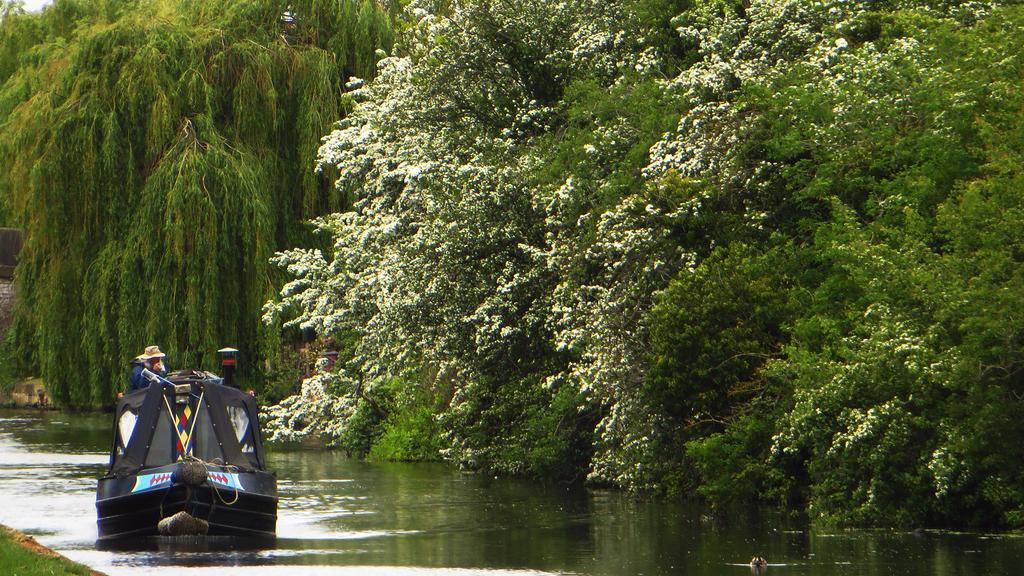What type of vegetation can be seen in the image? There are trees in the image. What is the color of the grass in the image? There is green grass in the image. What is the color of the boat in the image? There is a black boat in the image. Can you describe the person on the boat? There is a person on the boat. What is the primary element visible in the image? There is water visible in the image. What type of heart-shaped object can be seen on the person's face in the image? There is no heart-shaped object present on the person's face in the image. Is the person wearing a mask in the image? There is no mention of a mask in the image, so it cannot be determined if the person is wearing one. 